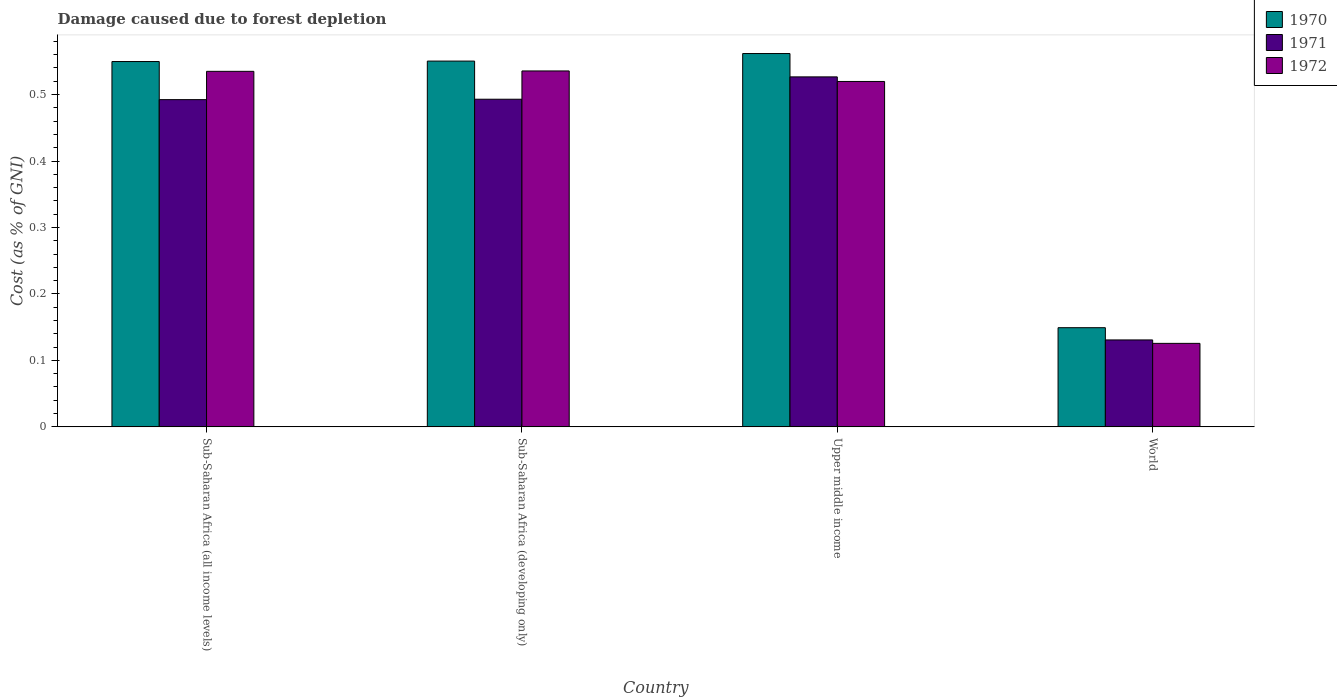How many groups of bars are there?
Your answer should be very brief. 4. Are the number of bars per tick equal to the number of legend labels?
Your answer should be compact. Yes. Are the number of bars on each tick of the X-axis equal?
Provide a short and direct response. Yes. How many bars are there on the 1st tick from the right?
Your response must be concise. 3. What is the label of the 1st group of bars from the left?
Provide a succinct answer. Sub-Saharan Africa (all income levels). In how many cases, is the number of bars for a given country not equal to the number of legend labels?
Your response must be concise. 0. What is the cost of damage caused due to forest depletion in 1970 in World?
Your answer should be very brief. 0.15. Across all countries, what is the maximum cost of damage caused due to forest depletion in 1972?
Offer a very short reply. 0.54. Across all countries, what is the minimum cost of damage caused due to forest depletion in 1972?
Provide a succinct answer. 0.13. In which country was the cost of damage caused due to forest depletion in 1971 maximum?
Make the answer very short. Upper middle income. In which country was the cost of damage caused due to forest depletion in 1971 minimum?
Make the answer very short. World. What is the total cost of damage caused due to forest depletion in 1970 in the graph?
Your answer should be very brief. 1.81. What is the difference between the cost of damage caused due to forest depletion in 1972 in Upper middle income and that in World?
Your response must be concise. 0.39. What is the difference between the cost of damage caused due to forest depletion in 1971 in Upper middle income and the cost of damage caused due to forest depletion in 1970 in World?
Offer a very short reply. 0.38. What is the average cost of damage caused due to forest depletion in 1972 per country?
Your response must be concise. 0.43. What is the difference between the cost of damage caused due to forest depletion of/in 1971 and cost of damage caused due to forest depletion of/in 1972 in World?
Make the answer very short. 0.01. What is the ratio of the cost of damage caused due to forest depletion in 1970 in Sub-Saharan Africa (developing only) to that in Upper middle income?
Your answer should be very brief. 0.98. What is the difference between the highest and the second highest cost of damage caused due to forest depletion in 1970?
Make the answer very short. 0.01. What is the difference between the highest and the lowest cost of damage caused due to forest depletion in 1971?
Offer a very short reply. 0.4. In how many countries, is the cost of damage caused due to forest depletion in 1972 greater than the average cost of damage caused due to forest depletion in 1972 taken over all countries?
Offer a terse response. 3. Is the sum of the cost of damage caused due to forest depletion in 1970 in Sub-Saharan Africa (developing only) and Upper middle income greater than the maximum cost of damage caused due to forest depletion in 1972 across all countries?
Offer a very short reply. Yes. What does the 3rd bar from the left in Upper middle income represents?
Ensure brevity in your answer.  1972. How many bars are there?
Give a very brief answer. 12. Are all the bars in the graph horizontal?
Offer a very short reply. No. Does the graph contain any zero values?
Your response must be concise. No. Where does the legend appear in the graph?
Offer a very short reply. Top right. What is the title of the graph?
Your answer should be compact. Damage caused due to forest depletion. Does "1983" appear as one of the legend labels in the graph?
Keep it short and to the point. No. What is the label or title of the Y-axis?
Provide a short and direct response. Cost (as % of GNI). What is the Cost (as % of GNI) of 1970 in Sub-Saharan Africa (all income levels)?
Your answer should be very brief. 0.55. What is the Cost (as % of GNI) of 1971 in Sub-Saharan Africa (all income levels)?
Offer a very short reply. 0.49. What is the Cost (as % of GNI) of 1972 in Sub-Saharan Africa (all income levels)?
Your response must be concise. 0.53. What is the Cost (as % of GNI) in 1970 in Sub-Saharan Africa (developing only)?
Provide a succinct answer. 0.55. What is the Cost (as % of GNI) in 1971 in Sub-Saharan Africa (developing only)?
Provide a succinct answer. 0.49. What is the Cost (as % of GNI) in 1972 in Sub-Saharan Africa (developing only)?
Provide a short and direct response. 0.54. What is the Cost (as % of GNI) in 1970 in Upper middle income?
Make the answer very short. 0.56. What is the Cost (as % of GNI) of 1971 in Upper middle income?
Your response must be concise. 0.53. What is the Cost (as % of GNI) of 1972 in Upper middle income?
Give a very brief answer. 0.52. What is the Cost (as % of GNI) of 1970 in World?
Keep it short and to the point. 0.15. What is the Cost (as % of GNI) of 1971 in World?
Your answer should be very brief. 0.13. What is the Cost (as % of GNI) of 1972 in World?
Your response must be concise. 0.13. Across all countries, what is the maximum Cost (as % of GNI) in 1970?
Keep it short and to the point. 0.56. Across all countries, what is the maximum Cost (as % of GNI) of 1971?
Your answer should be compact. 0.53. Across all countries, what is the maximum Cost (as % of GNI) in 1972?
Your response must be concise. 0.54. Across all countries, what is the minimum Cost (as % of GNI) in 1970?
Keep it short and to the point. 0.15. Across all countries, what is the minimum Cost (as % of GNI) of 1971?
Your response must be concise. 0.13. Across all countries, what is the minimum Cost (as % of GNI) of 1972?
Offer a terse response. 0.13. What is the total Cost (as % of GNI) in 1970 in the graph?
Make the answer very short. 1.81. What is the total Cost (as % of GNI) in 1971 in the graph?
Keep it short and to the point. 1.64. What is the total Cost (as % of GNI) in 1972 in the graph?
Offer a terse response. 1.72. What is the difference between the Cost (as % of GNI) in 1970 in Sub-Saharan Africa (all income levels) and that in Sub-Saharan Africa (developing only)?
Make the answer very short. -0. What is the difference between the Cost (as % of GNI) of 1971 in Sub-Saharan Africa (all income levels) and that in Sub-Saharan Africa (developing only)?
Offer a terse response. -0. What is the difference between the Cost (as % of GNI) in 1972 in Sub-Saharan Africa (all income levels) and that in Sub-Saharan Africa (developing only)?
Your response must be concise. -0. What is the difference between the Cost (as % of GNI) of 1970 in Sub-Saharan Africa (all income levels) and that in Upper middle income?
Your answer should be compact. -0.01. What is the difference between the Cost (as % of GNI) of 1971 in Sub-Saharan Africa (all income levels) and that in Upper middle income?
Offer a terse response. -0.03. What is the difference between the Cost (as % of GNI) in 1972 in Sub-Saharan Africa (all income levels) and that in Upper middle income?
Offer a terse response. 0.02. What is the difference between the Cost (as % of GNI) of 1970 in Sub-Saharan Africa (all income levels) and that in World?
Offer a terse response. 0.4. What is the difference between the Cost (as % of GNI) in 1971 in Sub-Saharan Africa (all income levels) and that in World?
Ensure brevity in your answer.  0.36. What is the difference between the Cost (as % of GNI) of 1972 in Sub-Saharan Africa (all income levels) and that in World?
Provide a succinct answer. 0.41. What is the difference between the Cost (as % of GNI) in 1970 in Sub-Saharan Africa (developing only) and that in Upper middle income?
Your answer should be compact. -0.01. What is the difference between the Cost (as % of GNI) in 1971 in Sub-Saharan Africa (developing only) and that in Upper middle income?
Offer a very short reply. -0.03. What is the difference between the Cost (as % of GNI) of 1972 in Sub-Saharan Africa (developing only) and that in Upper middle income?
Make the answer very short. 0.02. What is the difference between the Cost (as % of GNI) in 1970 in Sub-Saharan Africa (developing only) and that in World?
Offer a very short reply. 0.4. What is the difference between the Cost (as % of GNI) of 1971 in Sub-Saharan Africa (developing only) and that in World?
Your answer should be compact. 0.36. What is the difference between the Cost (as % of GNI) of 1972 in Sub-Saharan Africa (developing only) and that in World?
Provide a short and direct response. 0.41. What is the difference between the Cost (as % of GNI) in 1970 in Upper middle income and that in World?
Keep it short and to the point. 0.41. What is the difference between the Cost (as % of GNI) of 1971 in Upper middle income and that in World?
Your answer should be compact. 0.4. What is the difference between the Cost (as % of GNI) in 1972 in Upper middle income and that in World?
Your answer should be very brief. 0.39. What is the difference between the Cost (as % of GNI) in 1970 in Sub-Saharan Africa (all income levels) and the Cost (as % of GNI) in 1971 in Sub-Saharan Africa (developing only)?
Offer a very short reply. 0.06. What is the difference between the Cost (as % of GNI) in 1970 in Sub-Saharan Africa (all income levels) and the Cost (as % of GNI) in 1972 in Sub-Saharan Africa (developing only)?
Offer a terse response. 0.01. What is the difference between the Cost (as % of GNI) in 1971 in Sub-Saharan Africa (all income levels) and the Cost (as % of GNI) in 1972 in Sub-Saharan Africa (developing only)?
Provide a short and direct response. -0.04. What is the difference between the Cost (as % of GNI) in 1970 in Sub-Saharan Africa (all income levels) and the Cost (as % of GNI) in 1971 in Upper middle income?
Ensure brevity in your answer.  0.02. What is the difference between the Cost (as % of GNI) of 1971 in Sub-Saharan Africa (all income levels) and the Cost (as % of GNI) of 1972 in Upper middle income?
Your answer should be very brief. -0.03. What is the difference between the Cost (as % of GNI) in 1970 in Sub-Saharan Africa (all income levels) and the Cost (as % of GNI) in 1971 in World?
Give a very brief answer. 0.42. What is the difference between the Cost (as % of GNI) of 1970 in Sub-Saharan Africa (all income levels) and the Cost (as % of GNI) of 1972 in World?
Provide a short and direct response. 0.42. What is the difference between the Cost (as % of GNI) of 1971 in Sub-Saharan Africa (all income levels) and the Cost (as % of GNI) of 1972 in World?
Make the answer very short. 0.37. What is the difference between the Cost (as % of GNI) in 1970 in Sub-Saharan Africa (developing only) and the Cost (as % of GNI) in 1971 in Upper middle income?
Your response must be concise. 0.02. What is the difference between the Cost (as % of GNI) of 1970 in Sub-Saharan Africa (developing only) and the Cost (as % of GNI) of 1972 in Upper middle income?
Make the answer very short. 0.03. What is the difference between the Cost (as % of GNI) in 1971 in Sub-Saharan Africa (developing only) and the Cost (as % of GNI) in 1972 in Upper middle income?
Your answer should be compact. -0.03. What is the difference between the Cost (as % of GNI) in 1970 in Sub-Saharan Africa (developing only) and the Cost (as % of GNI) in 1971 in World?
Ensure brevity in your answer.  0.42. What is the difference between the Cost (as % of GNI) in 1970 in Sub-Saharan Africa (developing only) and the Cost (as % of GNI) in 1972 in World?
Give a very brief answer. 0.42. What is the difference between the Cost (as % of GNI) in 1971 in Sub-Saharan Africa (developing only) and the Cost (as % of GNI) in 1972 in World?
Ensure brevity in your answer.  0.37. What is the difference between the Cost (as % of GNI) in 1970 in Upper middle income and the Cost (as % of GNI) in 1971 in World?
Ensure brevity in your answer.  0.43. What is the difference between the Cost (as % of GNI) of 1970 in Upper middle income and the Cost (as % of GNI) of 1972 in World?
Offer a very short reply. 0.44. What is the difference between the Cost (as % of GNI) in 1971 in Upper middle income and the Cost (as % of GNI) in 1972 in World?
Provide a succinct answer. 0.4. What is the average Cost (as % of GNI) of 1970 per country?
Give a very brief answer. 0.45. What is the average Cost (as % of GNI) in 1971 per country?
Your answer should be compact. 0.41. What is the average Cost (as % of GNI) in 1972 per country?
Keep it short and to the point. 0.43. What is the difference between the Cost (as % of GNI) of 1970 and Cost (as % of GNI) of 1971 in Sub-Saharan Africa (all income levels)?
Provide a short and direct response. 0.06. What is the difference between the Cost (as % of GNI) in 1970 and Cost (as % of GNI) in 1972 in Sub-Saharan Africa (all income levels)?
Offer a terse response. 0.01. What is the difference between the Cost (as % of GNI) of 1971 and Cost (as % of GNI) of 1972 in Sub-Saharan Africa (all income levels)?
Offer a very short reply. -0.04. What is the difference between the Cost (as % of GNI) in 1970 and Cost (as % of GNI) in 1971 in Sub-Saharan Africa (developing only)?
Your answer should be compact. 0.06. What is the difference between the Cost (as % of GNI) of 1970 and Cost (as % of GNI) of 1972 in Sub-Saharan Africa (developing only)?
Give a very brief answer. 0.01. What is the difference between the Cost (as % of GNI) of 1971 and Cost (as % of GNI) of 1972 in Sub-Saharan Africa (developing only)?
Your answer should be compact. -0.04. What is the difference between the Cost (as % of GNI) of 1970 and Cost (as % of GNI) of 1971 in Upper middle income?
Your answer should be very brief. 0.04. What is the difference between the Cost (as % of GNI) in 1970 and Cost (as % of GNI) in 1972 in Upper middle income?
Make the answer very short. 0.04. What is the difference between the Cost (as % of GNI) in 1971 and Cost (as % of GNI) in 1972 in Upper middle income?
Make the answer very short. 0.01. What is the difference between the Cost (as % of GNI) of 1970 and Cost (as % of GNI) of 1971 in World?
Offer a very short reply. 0.02. What is the difference between the Cost (as % of GNI) in 1970 and Cost (as % of GNI) in 1972 in World?
Offer a very short reply. 0.02. What is the difference between the Cost (as % of GNI) in 1971 and Cost (as % of GNI) in 1972 in World?
Your answer should be compact. 0.01. What is the ratio of the Cost (as % of GNI) of 1970 in Sub-Saharan Africa (all income levels) to that in Sub-Saharan Africa (developing only)?
Offer a terse response. 1. What is the ratio of the Cost (as % of GNI) in 1971 in Sub-Saharan Africa (all income levels) to that in Sub-Saharan Africa (developing only)?
Keep it short and to the point. 1. What is the ratio of the Cost (as % of GNI) of 1972 in Sub-Saharan Africa (all income levels) to that in Sub-Saharan Africa (developing only)?
Your response must be concise. 1. What is the ratio of the Cost (as % of GNI) in 1970 in Sub-Saharan Africa (all income levels) to that in Upper middle income?
Provide a succinct answer. 0.98. What is the ratio of the Cost (as % of GNI) in 1971 in Sub-Saharan Africa (all income levels) to that in Upper middle income?
Your answer should be very brief. 0.94. What is the ratio of the Cost (as % of GNI) of 1972 in Sub-Saharan Africa (all income levels) to that in Upper middle income?
Offer a terse response. 1.03. What is the ratio of the Cost (as % of GNI) in 1970 in Sub-Saharan Africa (all income levels) to that in World?
Your answer should be compact. 3.68. What is the ratio of the Cost (as % of GNI) of 1971 in Sub-Saharan Africa (all income levels) to that in World?
Your answer should be very brief. 3.76. What is the ratio of the Cost (as % of GNI) in 1972 in Sub-Saharan Africa (all income levels) to that in World?
Keep it short and to the point. 4.26. What is the ratio of the Cost (as % of GNI) in 1970 in Sub-Saharan Africa (developing only) to that in Upper middle income?
Make the answer very short. 0.98. What is the ratio of the Cost (as % of GNI) of 1971 in Sub-Saharan Africa (developing only) to that in Upper middle income?
Your response must be concise. 0.94. What is the ratio of the Cost (as % of GNI) of 1972 in Sub-Saharan Africa (developing only) to that in Upper middle income?
Give a very brief answer. 1.03. What is the ratio of the Cost (as % of GNI) of 1970 in Sub-Saharan Africa (developing only) to that in World?
Make the answer very short. 3.69. What is the ratio of the Cost (as % of GNI) of 1971 in Sub-Saharan Africa (developing only) to that in World?
Offer a terse response. 3.77. What is the ratio of the Cost (as % of GNI) in 1972 in Sub-Saharan Africa (developing only) to that in World?
Provide a succinct answer. 4.26. What is the ratio of the Cost (as % of GNI) in 1970 in Upper middle income to that in World?
Give a very brief answer. 3.76. What is the ratio of the Cost (as % of GNI) in 1971 in Upper middle income to that in World?
Your answer should be compact. 4.03. What is the ratio of the Cost (as % of GNI) of 1972 in Upper middle income to that in World?
Your answer should be very brief. 4.14. What is the difference between the highest and the second highest Cost (as % of GNI) of 1970?
Ensure brevity in your answer.  0.01. What is the difference between the highest and the second highest Cost (as % of GNI) of 1971?
Ensure brevity in your answer.  0.03. What is the difference between the highest and the second highest Cost (as % of GNI) of 1972?
Your answer should be very brief. 0. What is the difference between the highest and the lowest Cost (as % of GNI) of 1970?
Your answer should be very brief. 0.41. What is the difference between the highest and the lowest Cost (as % of GNI) of 1971?
Provide a short and direct response. 0.4. What is the difference between the highest and the lowest Cost (as % of GNI) of 1972?
Make the answer very short. 0.41. 